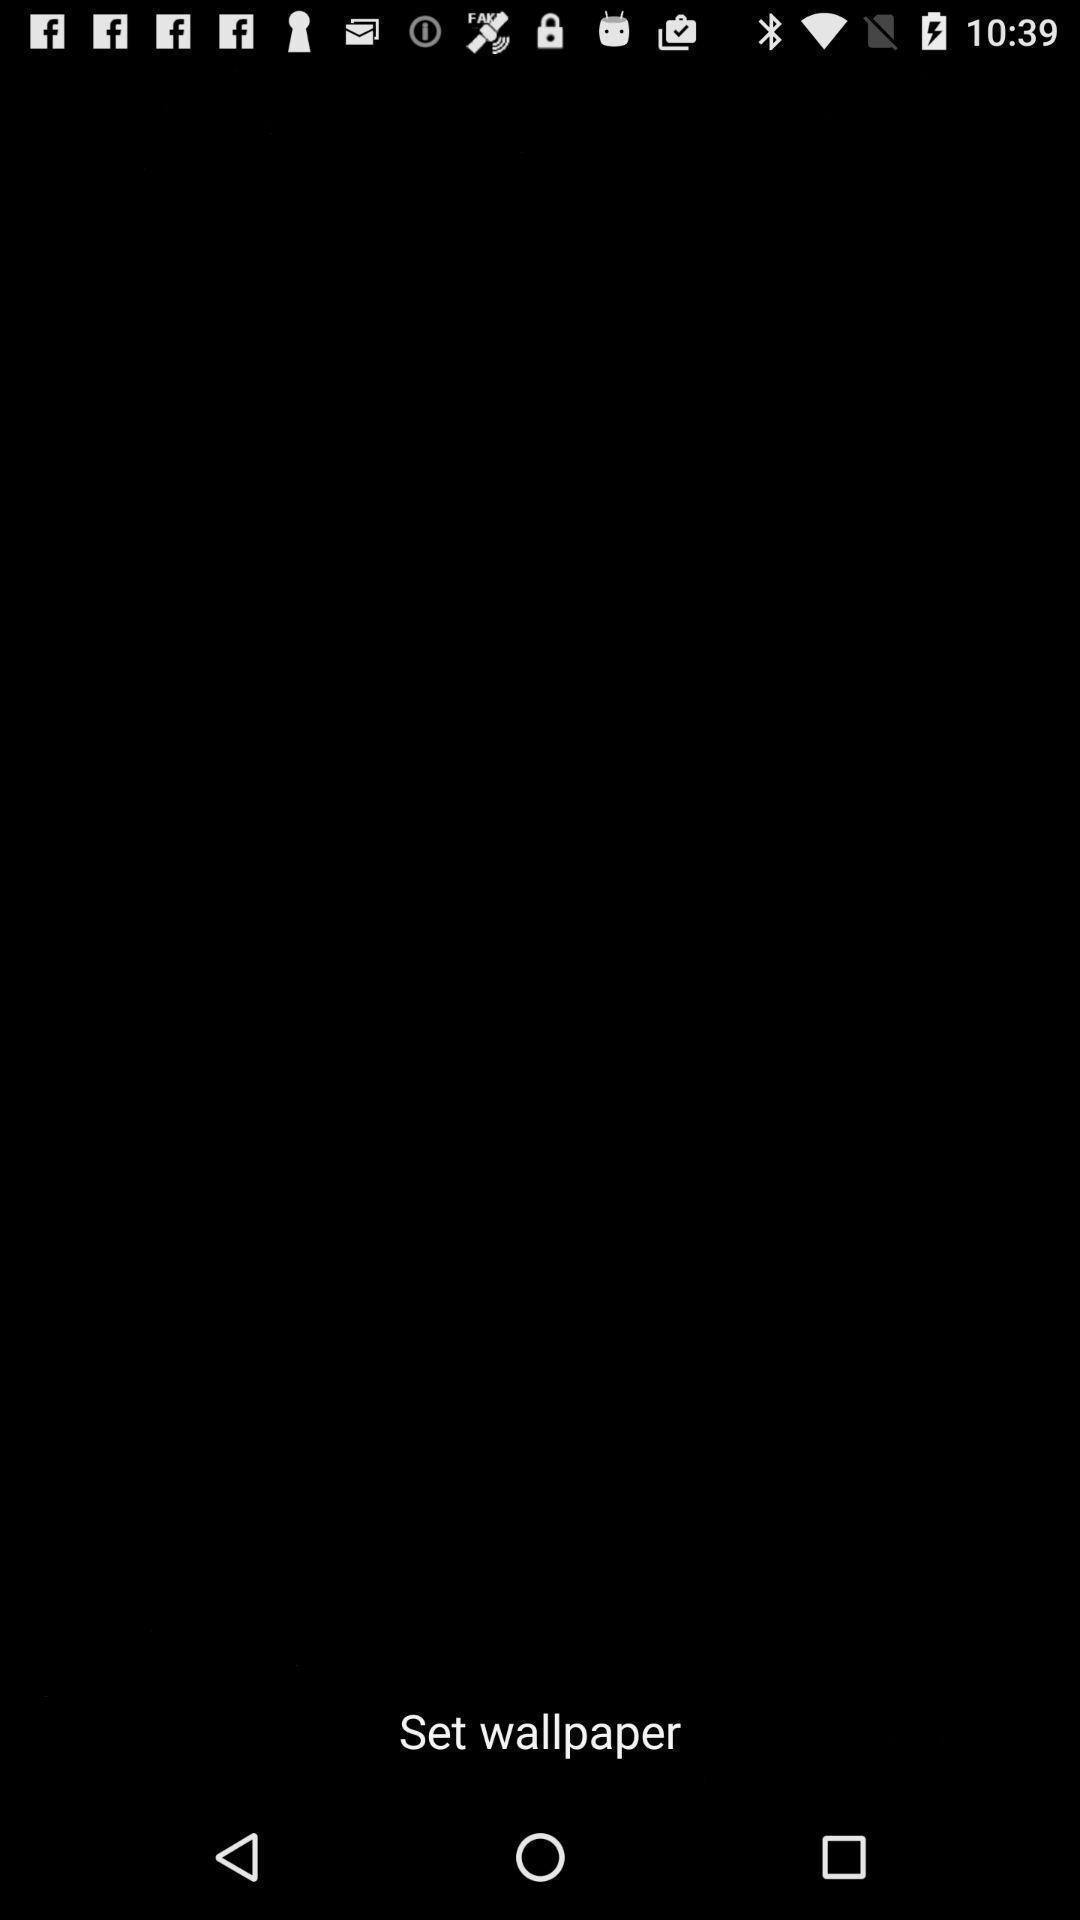What details can you identify in this image? Page displaying to set wallpaper. 